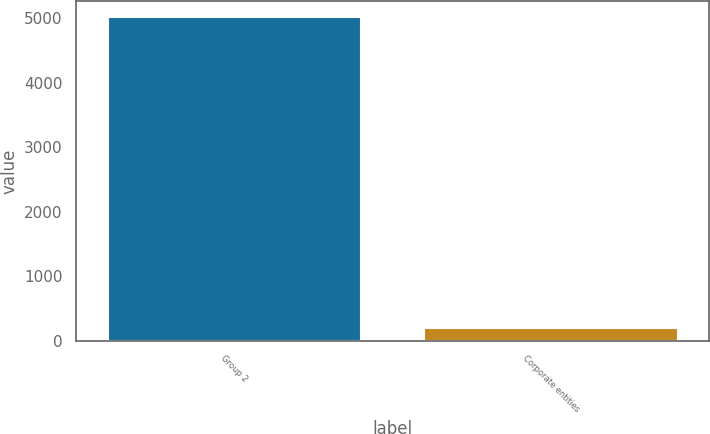Convert chart. <chart><loc_0><loc_0><loc_500><loc_500><bar_chart><fcel>Group 2<fcel>Corporate entities<nl><fcel>5013.5<fcel>188.9<nl></chart> 